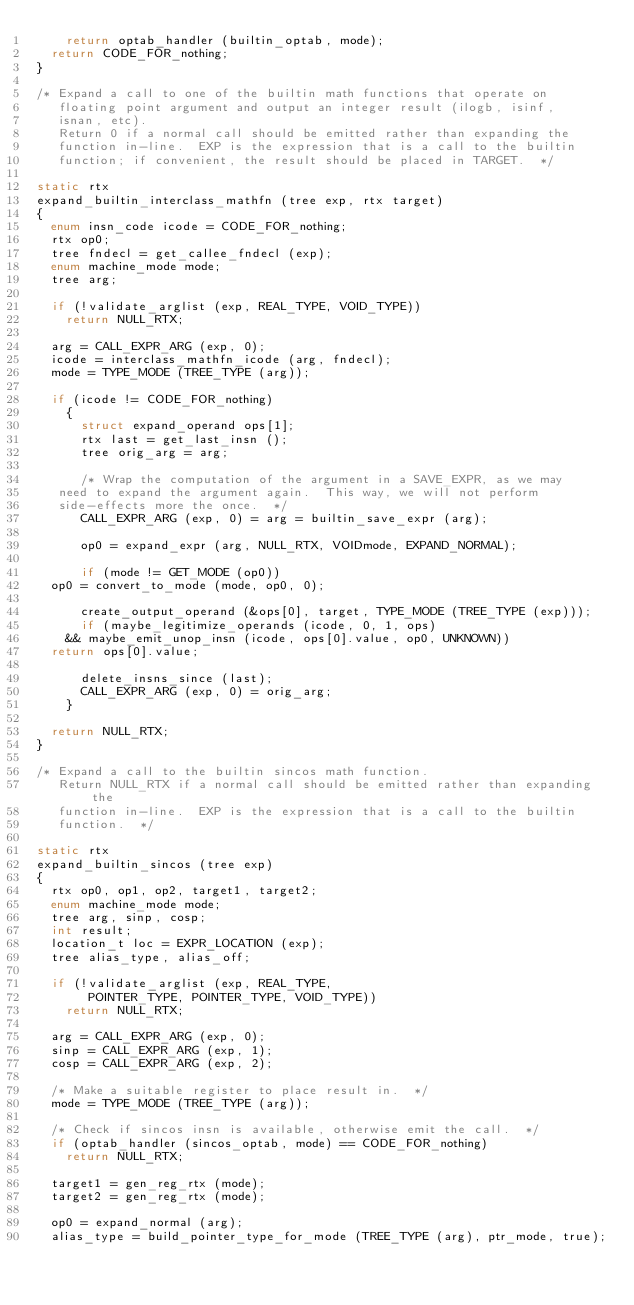<code> <loc_0><loc_0><loc_500><loc_500><_C_>    return optab_handler (builtin_optab, mode);
  return CODE_FOR_nothing;
}

/* Expand a call to one of the builtin math functions that operate on
   floating point argument and output an integer result (ilogb, isinf,
   isnan, etc).
   Return 0 if a normal call should be emitted rather than expanding the
   function in-line.  EXP is the expression that is a call to the builtin
   function; if convenient, the result should be placed in TARGET.  */

static rtx
expand_builtin_interclass_mathfn (tree exp, rtx target)
{
  enum insn_code icode = CODE_FOR_nothing;
  rtx op0;
  tree fndecl = get_callee_fndecl (exp);
  enum machine_mode mode;
  tree arg;

  if (!validate_arglist (exp, REAL_TYPE, VOID_TYPE))
    return NULL_RTX;

  arg = CALL_EXPR_ARG (exp, 0);
  icode = interclass_mathfn_icode (arg, fndecl);
  mode = TYPE_MODE (TREE_TYPE (arg));

  if (icode != CODE_FOR_nothing)
    {
      struct expand_operand ops[1];
      rtx last = get_last_insn ();
      tree orig_arg = arg;

      /* Wrap the computation of the argument in a SAVE_EXPR, as we may
	 need to expand the argument again.  This way, we will not perform
	 side-effects more the once.  */
      CALL_EXPR_ARG (exp, 0) = arg = builtin_save_expr (arg);

      op0 = expand_expr (arg, NULL_RTX, VOIDmode, EXPAND_NORMAL);

      if (mode != GET_MODE (op0))
	op0 = convert_to_mode (mode, op0, 0);

      create_output_operand (&ops[0], target, TYPE_MODE (TREE_TYPE (exp)));
      if (maybe_legitimize_operands (icode, 0, 1, ops)
	  && maybe_emit_unop_insn (icode, ops[0].value, op0, UNKNOWN))
	return ops[0].value;

      delete_insns_since (last);
      CALL_EXPR_ARG (exp, 0) = orig_arg;
    }

  return NULL_RTX;
}

/* Expand a call to the builtin sincos math function.
   Return NULL_RTX if a normal call should be emitted rather than expanding the
   function in-line.  EXP is the expression that is a call to the builtin
   function.  */

static rtx
expand_builtin_sincos (tree exp)
{
  rtx op0, op1, op2, target1, target2;
  enum machine_mode mode;
  tree arg, sinp, cosp;
  int result;
  location_t loc = EXPR_LOCATION (exp);
  tree alias_type, alias_off;

  if (!validate_arglist (exp, REAL_TYPE,
 			 POINTER_TYPE, POINTER_TYPE, VOID_TYPE))
    return NULL_RTX;

  arg = CALL_EXPR_ARG (exp, 0);
  sinp = CALL_EXPR_ARG (exp, 1);
  cosp = CALL_EXPR_ARG (exp, 2);

  /* Make a suitable register to place result in.  */
  mode = TYPE_MODE (TREE_TYPE (arg));

  /* Check if sincos insn is available, otherwise emit the call.  */
  if (optab_handler (sincos_optab, mode) == CODE_FOR_nothing)
    return NULL_RTX;

  target1 = gen_reg_rtx (mode);
  target2 = gen_reg_rtx (mode);

  op0 = expand_normal (arg);
  alias_type = build_pointer_type_for_mode (TREE_TYPE (arg), ptr_mode, true);</code> 